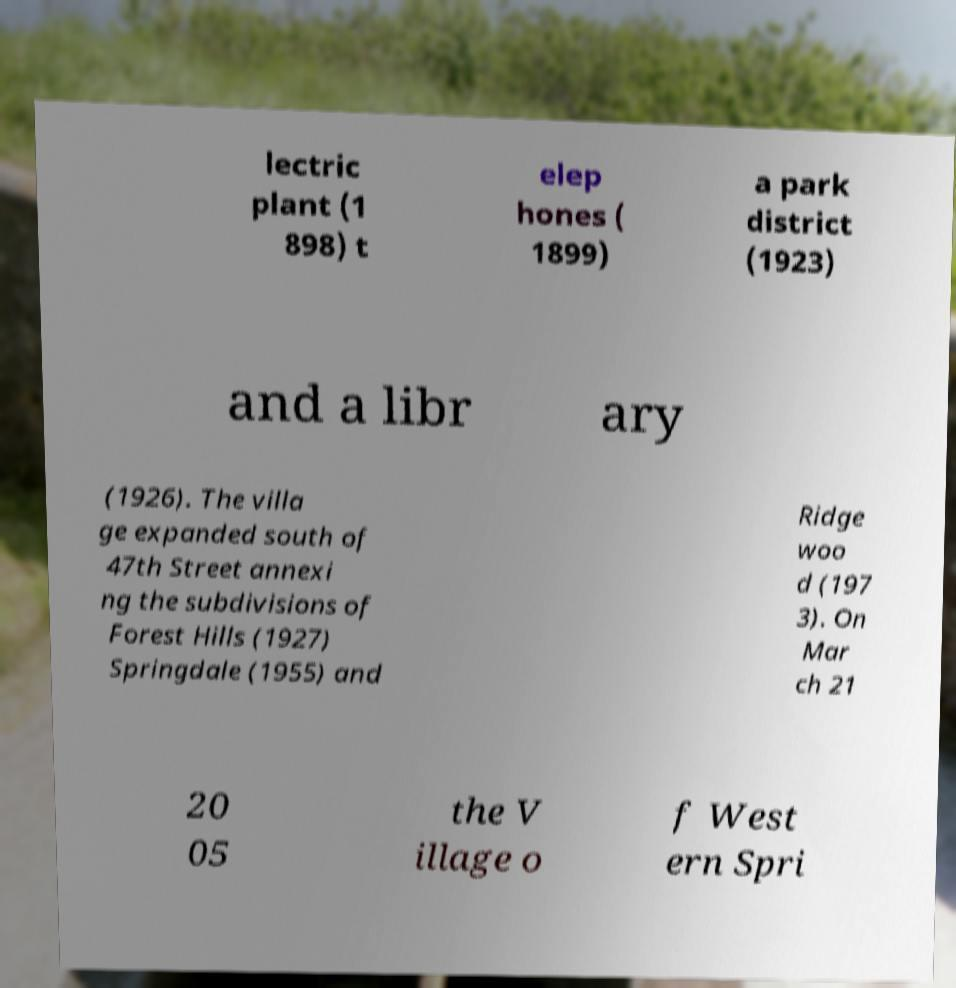Please read and relay the text visible in this image. What does it say? lectric plant (1 898) t elep hones ( 1899) a park district (1923) and a libr ary (1926). The villa ge expanded south of 47th Street annexi ng the subdivisions of Forest Hills (1927) Springdale (1955) and Ridge woo d (197 3). On Mar ch 21 20 05 the V illage o f West ern Spri 